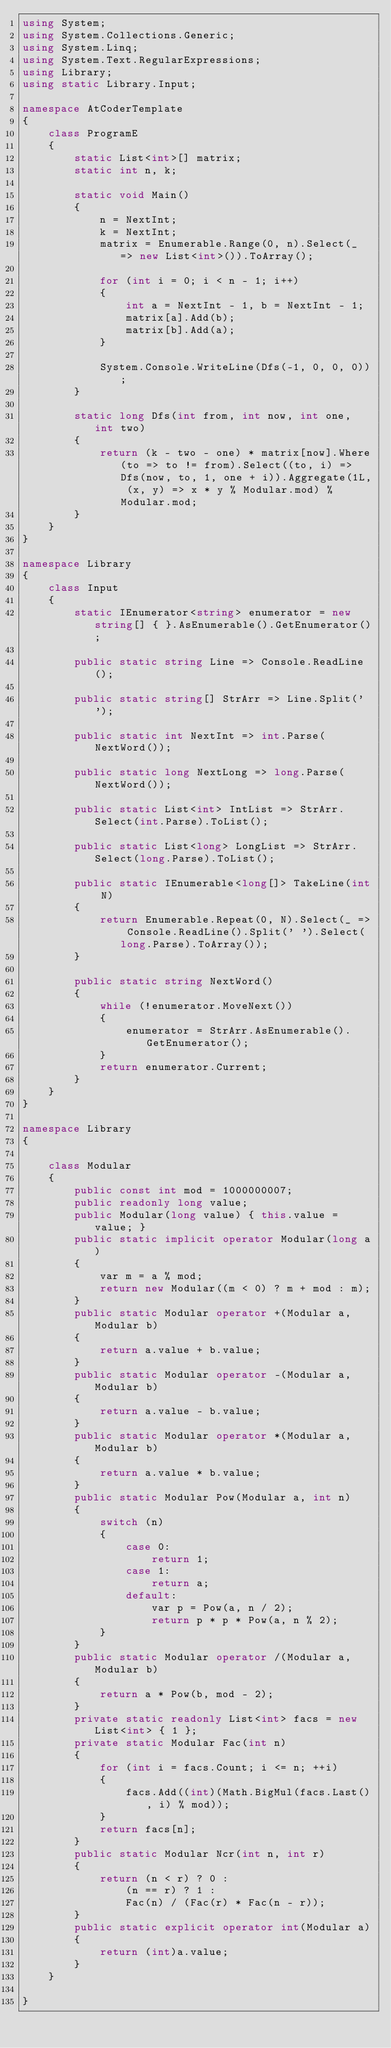Convert code to text. <code><loc_0><loc_0><loc_500><loc_500><_C#_>using System;
using System.Collections.Generic;
using System.Linq;
using System.Text.RegularExpressions;
using Library;
using static Library.Input;

namespace AtCoderTemplate
{
    class ProgramE
    {
        static List<int>[] matrix;
        static int n, k;

        static void Main()
        {
            n = NextInt;
            k = NextInt;
            matrix = Enumerable.Range(0, n).Select(_ => new List<int>()).ToArray();

            for (int i = 0; i < n - 1; i++)
            {
                int a = NextInt - 1, b = NextInt - 1;
                matrix[a].Add(b);
                matrix[b].Add(a);
            }

            System.Console.WriteLine(Dfs(-1, 0, 0, 0));
        }

        static long Dfs(int from, int now, int one, int two)
        {
            return (k - two - one) * matrix[now].Where(to => to != from).Select((to, i) => Dfs(now, to, 1, one + i)).Aggregate(1L, (x, y) => x * y % Modular.mod) % Modular.mod;
        }
    }
}

namespace Library
{
    class Input
    {
        static IEnumerator<string> enumerator = new string[] { }.AsEnumerable().GetEnumerator();

        public static string Line => Console.ReadLine();

        public static string[] StrArr => Line.Split(' ');

        public static int NextInt => int.Parse(NextWord());

        public static long NextLong => long.Parse(NextWord());

        public static List<int> IntList => StrArr.Select(int.Parse).ToList();

        public static List<long> LongList => StrArr.Select(long.Parse).ToList();

        public static IEnumerable<long[]> TakeLine(int N)
        {
            return Enumerable.Repeat(0, N).Select(_ => Console.ReadLine().Split(' ').Select(long.Parse).ToArray());
        }

        public static string NextWord()
        {
            while (!enumerator.MoveNext())
            {
                enumerator = StrArr.AsEnumerable().GetEnumerator();
            }
            return enumerator.Current;
        }
    }
}

namespace Library
{

    class Modular
    {
        public const int mod = 1000000007;
        public readonly long value;
        public Modular(long value) { this.value = value; }
        public static implicit operator Modular(long a)
        {
            var m = a % mod;
            return new Modular((m < 0) ? m + mod : m);
        }
        public static Modular operator +(Modular a, Modular b)
        {
            return a.value + b.value;
        }
        public static Modular operator -(Modular a, Modular b)
        {
            return a.value - b.value;
        }
        public static Modular operator *(Modular a, Modular b)
        {
            return a.value * b.value;
        }
        public static Modular Pow(Modular a, int n)
        {
            switch (n)
            {
                case 0:
                    return 1;
                case 1:
                    return a;
                default:
                    var p = Pow(a, n / 2);
                    return p * p * Pow(a, n % 2);
            }
        }
        public static Modular operator /(Modular a, Modular b)
        {
            return a * Pow(b, mod - 2);
        }
        private static readonly List<int> facs = new List<int> { 1 };
        private static Modular Fac(int n)
        {
            for (int i = facs.Count; i <= n; ++i)
            {
                facs.Add((int)(Math.BigMul(facs.Last(), i) % mod));
            }
            return facs[n];
        }
        public static Modular Ncr(int n, int r)
        {
            return (n < r) ? 0 :
                (n == r) ? 1 :
                Fac(n) / (Fac(r) * Fac(n - r));
        }
        public static explicit operator int(Modular a)
        {
            return (int)a.value;
        }
    }

}
</code> 